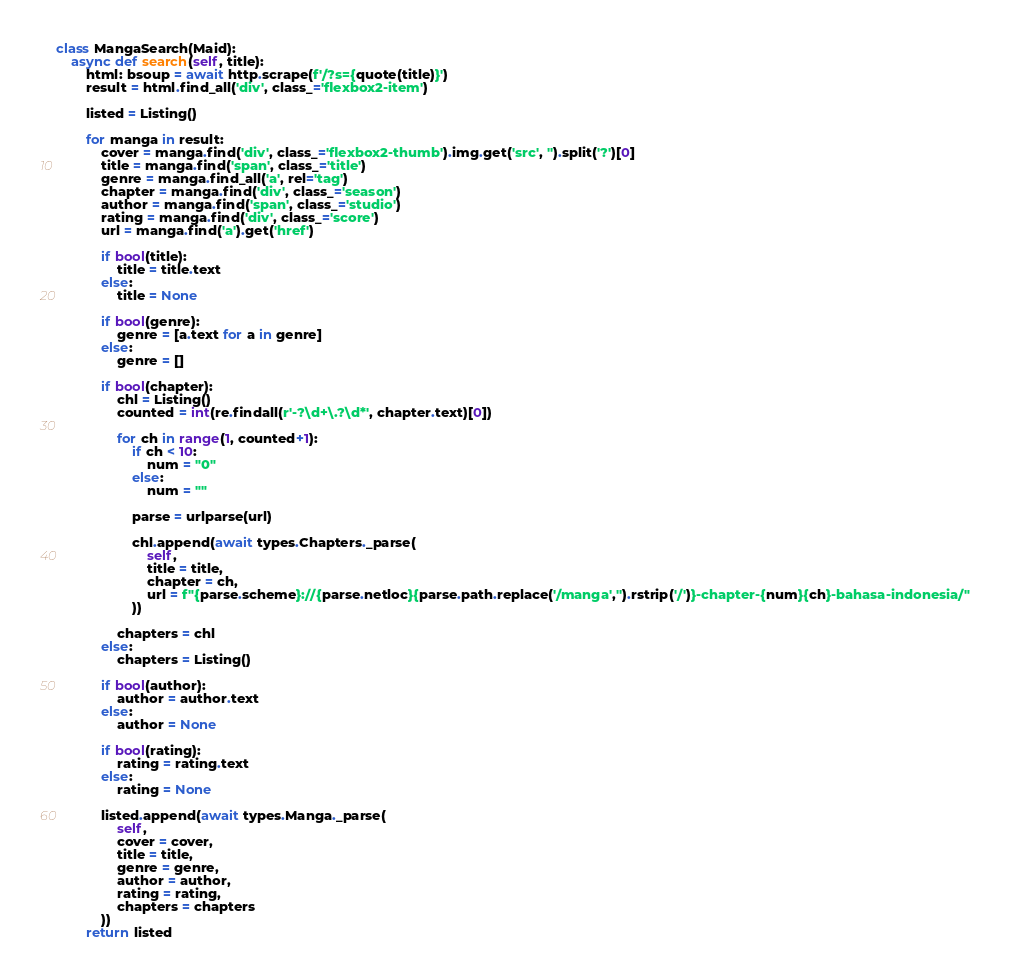<code> <loc_0><loc_0><loc_500><loc_500><_Python_>
class MangaSearch(Maid):
    async def search(self, title):
        html: bsoup = await http.scrape(f'/?s={quote(title)}')
        result = html.find_all('div', class_='flexbox2-item')

        listed = Listing()
        
        for manga in result:
            cover = manga.find('div', class_='flexbox2-thumb').img.get('src', '').split('?')[0]
            title = manga.find('span', class_='title')
            genre = manga.find_all('a', rel='tag')
            chapter = manga.find('div', class_='season')
            author = manga.find('span', class_='studio')
            rating = manga.find('div', class_='score')
            url = manga.find('a').get('href')

            if bool(title):
                title = title.text
            else:
                title = None

            if bool(genre):
                genre = [a.text for a in genre]
            else:
                genre = []

            if bool(chapter):
                chl = Listing()
                counted = int(re.findall(r'-?\d+\.?\d*', chapter.text)[0])

                for ch in range(1, counted+1):
                    if ch < 10:
                        num = "0"
                    else:
                        num = ""

                    parse = urlparse(url)

                    chl.append(await types.Chapters._parse(
                        self,
                        title = title,
                        chapter = ch,
                        url = f"{parse.scheme}://{parse.netloc}{parse.path.replace('/manga','').rstrip('/')}-chapter-{num}{ch}-bahasa-indonesia/"
                    ))

                chapters = chl
            else:
                chapters = Listing()

            if bool(author):
                author = author.text
            else:
                author = None

            if bool(rating):
                rating = rating.text
            else:
                rating = None

            listed.append(await types.Manga._parse(
                self,
                cover = cover,
                title = title,
                genre = genre,
                author = author,
                rating = rating,
                chapters = chapters
            ))
        return listed</code> 